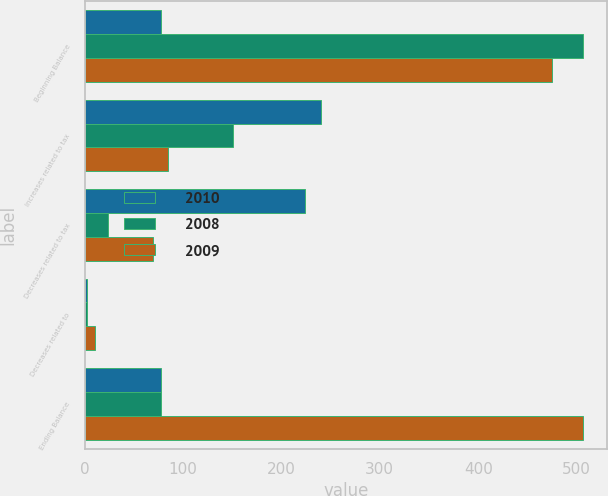Convert chart to OTSL. <chart><loc_0><loc_0><loc_500><loc_500><stacked_bar_chart><ecel><fcel>Beginning Balance<fcel>Increases related to tax<fcel>Decreases related to tax<fcel>Decreases related to<fcel>Ending Balance<nl><fcel>2010<fcel>77.5<fcel>240<fcel>224<fcel>3<fcel>77.5<nl><fcel>2008<fcel>506<fcel>151<fcel>24<fcel>3<fcel>77.5<nl><fcel>2009<fcel>475<fcel>85<fcel>70<fcel>11<fcel>506<nl></chart> 